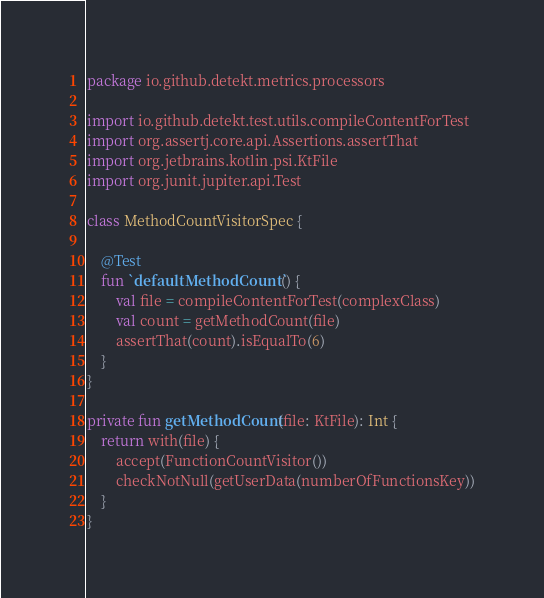Convert code to text. <code><loc_0><loc_0><loc_500><loc_500><_Kotlin_>package io.github.detekt.metrics.processors

import io.github.detekt.test.utils.compileContentForTest
import org.assertj.core.api.Assertions.assertThat
import org.jetbrains.kotlin.psi.KtFile
import org.junit.jupiter.api.Test

class MethodCountVisitorSpec {

    @Test
    fun `defaultMethodCount`() {
        val file = compileContentForTest(complexClass)
        val count = getMethodCount(file)
        assertThat(count).isEqualTo(6)
    }
}

private fun getMethodCount(file: KtFile): Int {
    return with(file) {
        accept(FunctionCountVisitor())
        checkNotNull(getUserData(numberOfFunctionsKey))
    }
}
</code> 